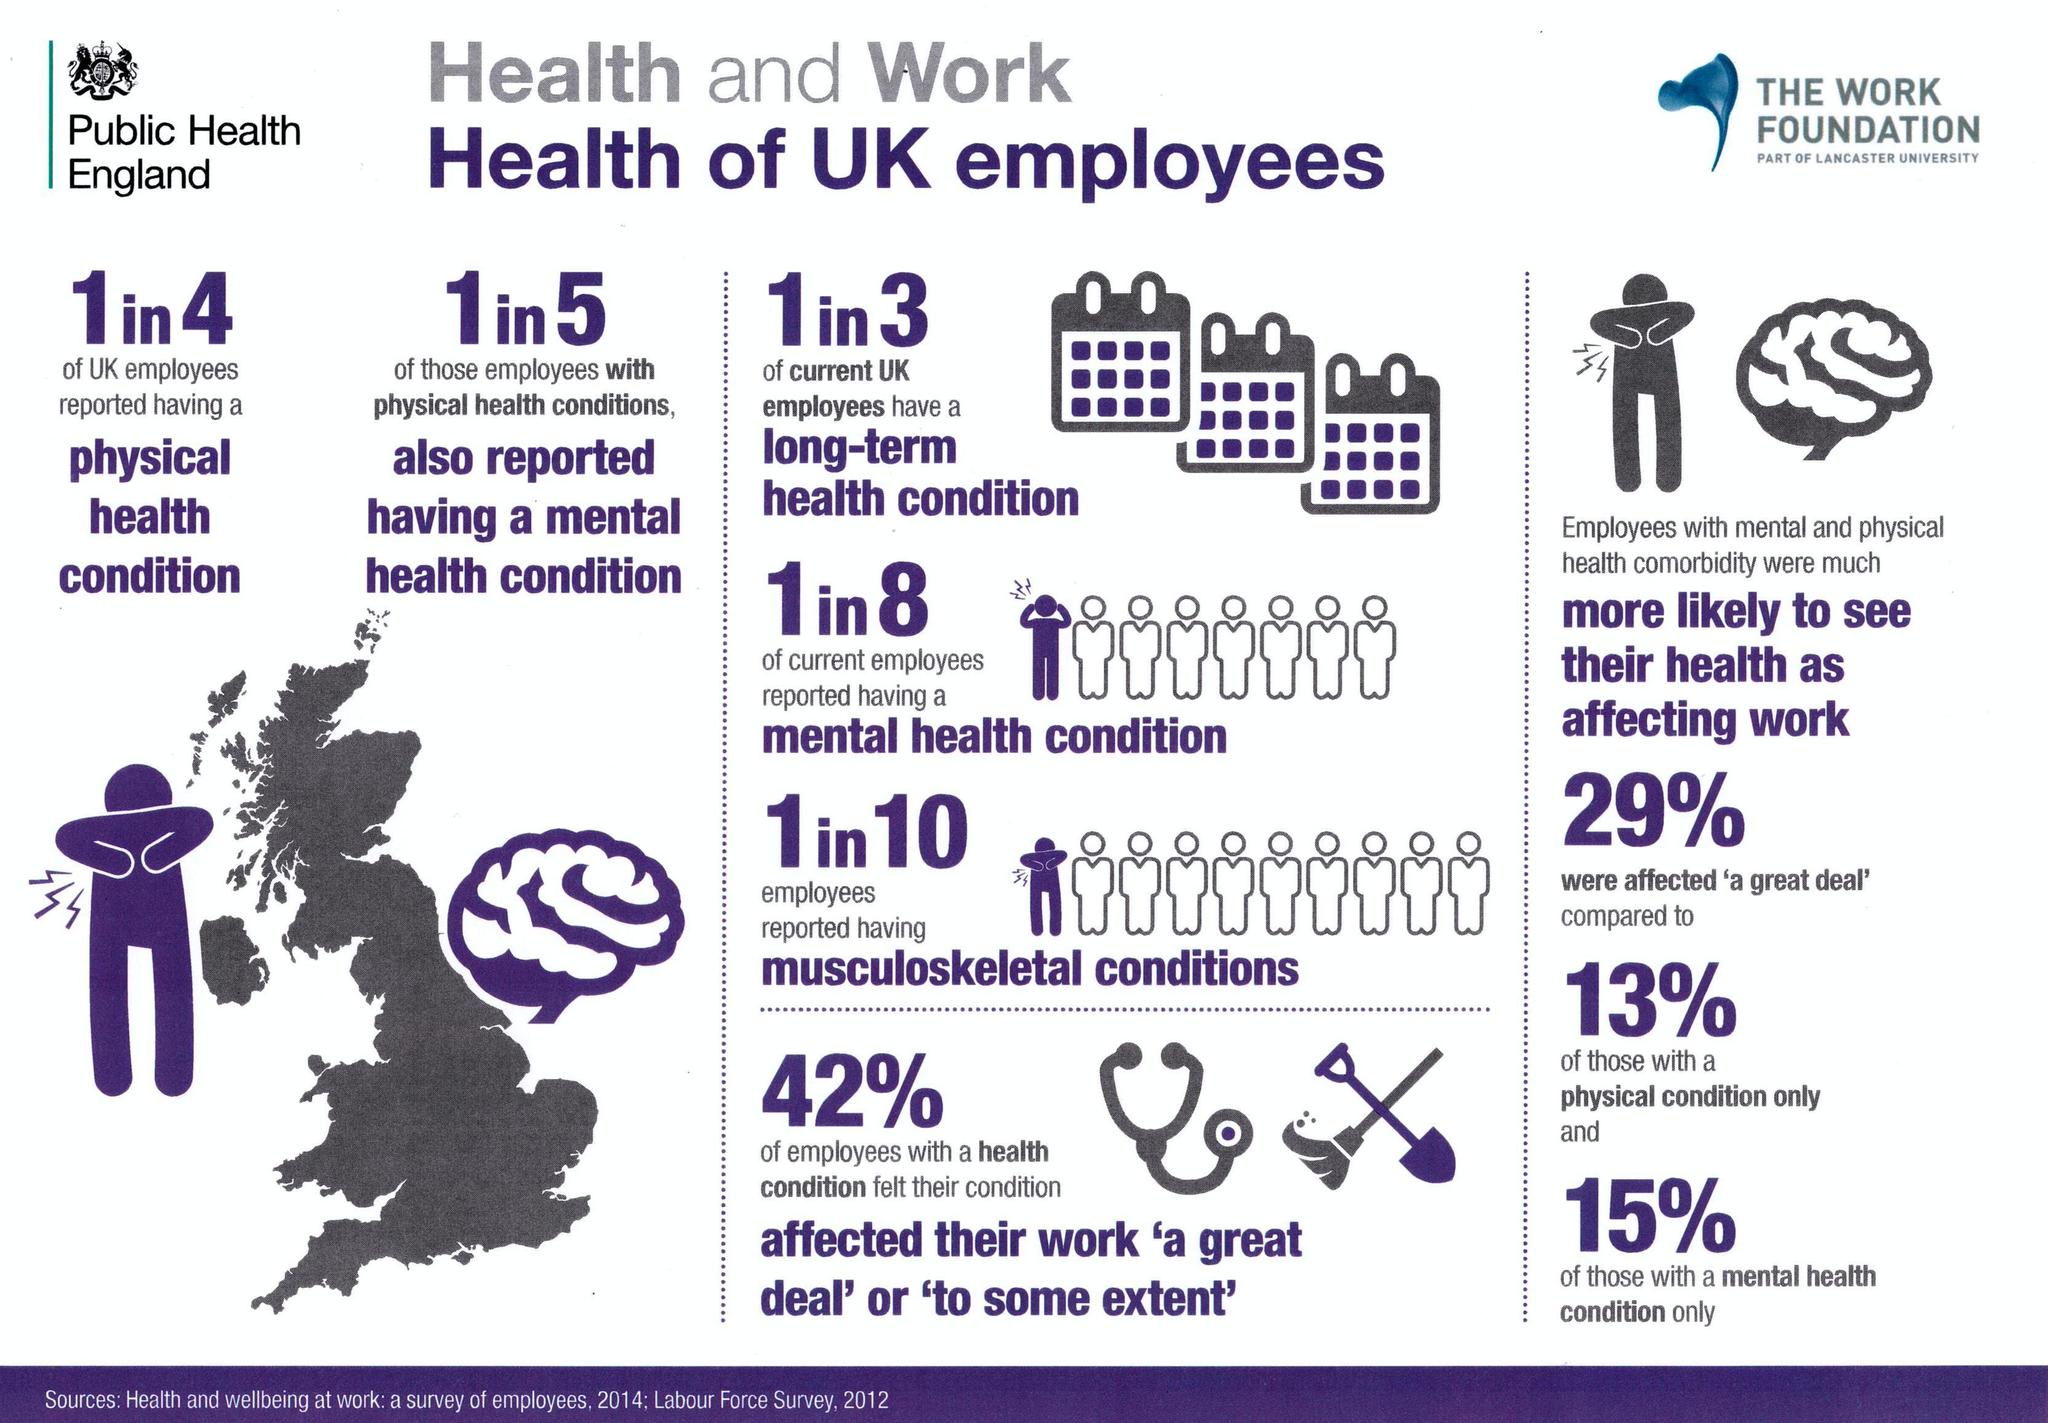What percentage of employees work in UK are not affected by their mental health condition only as per the survey?
Answer the question with a short phrase. 85% What percentage of employees work in UK are not affected by their health condition to some extend as per the survey? 58% 